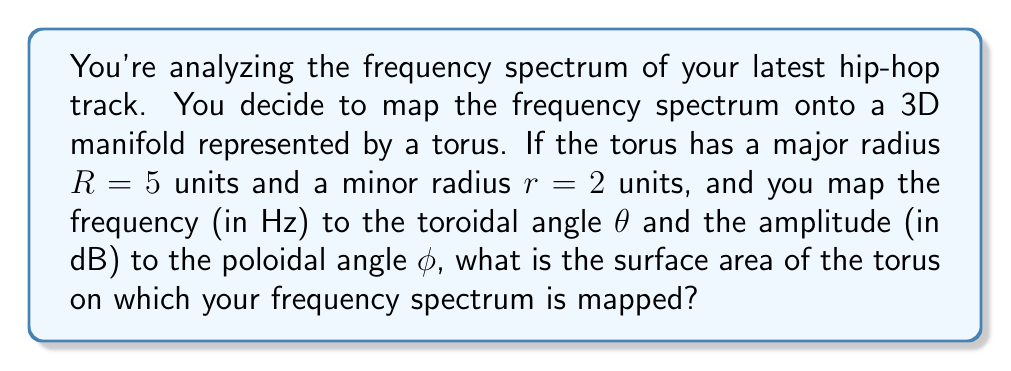Provide a solution to this math problem. To solve this problem, we need to follow these steps:

1) The surface area of a torus is given by the formula:

   $$A = 4\pi^2Rr$$

   where $R$ is the major radius (distance from the center of the tube to the center of the torus) and $r$ is the minor radius (radius of the tube).

2) We are given:
   $R = 5$ units
   $r = 2$ units

3) Let's substitute these values into the formula:

   $$A = 4\pi^2 \cdot 5 \cdot 2$$

4) Simplify:
   $$A = 40\pi^2$$

5) If we want to express this in square units:
   $$A \approx 395.84\text{ square units}$$

This surface area represents the space on which your frequency spectrum is mapped. The toroidal angle $\theta$ (representing frequency) wraps around the torus in the direction of the major radius, while the poloidal angle $\phi$ (representing amplitude) wraps around the tube of the torus.

This mapping allows you to visualize your track's frequency content in a unique 3D space, where patterns and relationships in the spectrum might become more apparent.
Answer: $40\pi^2$ square units, or approximately 395.84 square units 